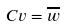Convert formula to latex. <formula><loc_0><loc_0><loc_500><loc_500>C v = \overline { w }</formula> 